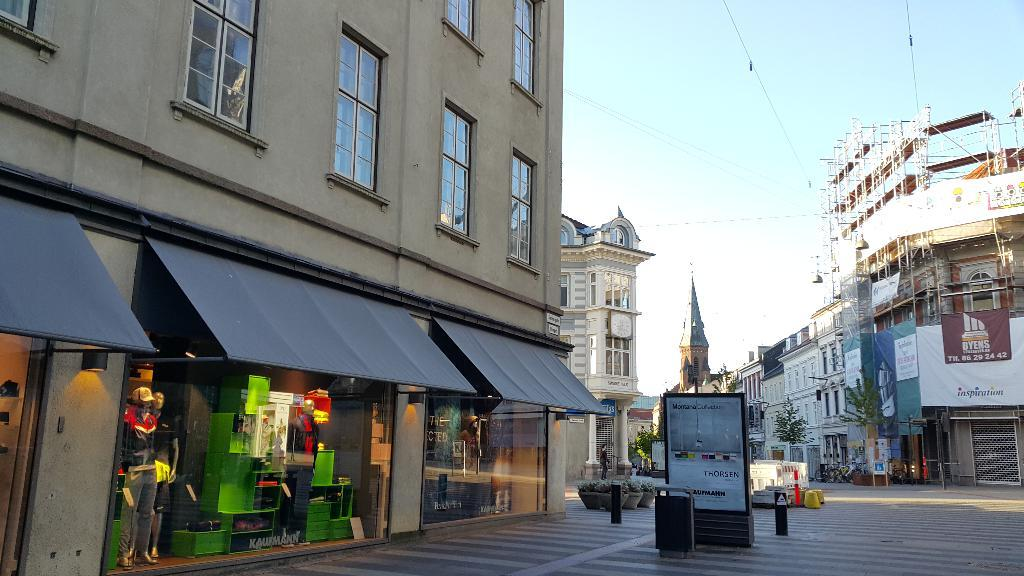What type of structures can be seen in the image? There are buildings in the image. What architectural features can be observed on the buildings? Windows are visible in the image. What objects are present near the buildings? There are boards and house plants in the image. What is the condition of the road in the image? Trees are on the road in the image. What is the color of the sky in the image? The sky is blue in the image. What other elements can be seen in the image? Wires are present in the image. When was the image taken? The image was taken during the day. How does the order of the buildings affect the digestion of the trees on the road? The order of the buildings does not affect the digestion of the trees on the road, as trees do not have a digestive system. 